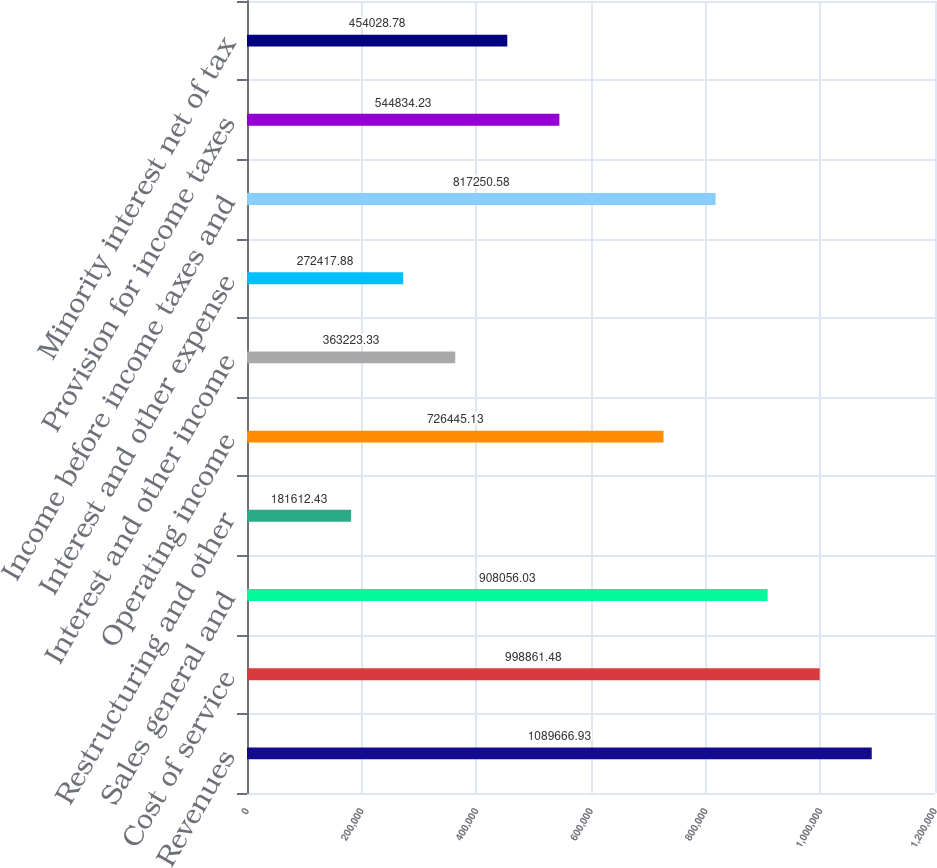<chart> <loc_0><loc_0><loc_500><loc_500><bar_chart><fcel>Revenues<fcel>Cost of service<fcel>Sales general and<fcel>Restructuring and other<fcel>Operating income<fcel>Interest and other income<fcel>Interest and other expense<fcel>Income before income taxes and<fcel>Provision for income taxes<fcel>Minority interest net of tax<nl><fcel>1.08967e+06<fcel>998861<fcel>908056<fcel>181612<fcel>726445<fcel>363223<fcel>272418<fcel>817251<fcel>544834<fcel>454029<nl></chart> 